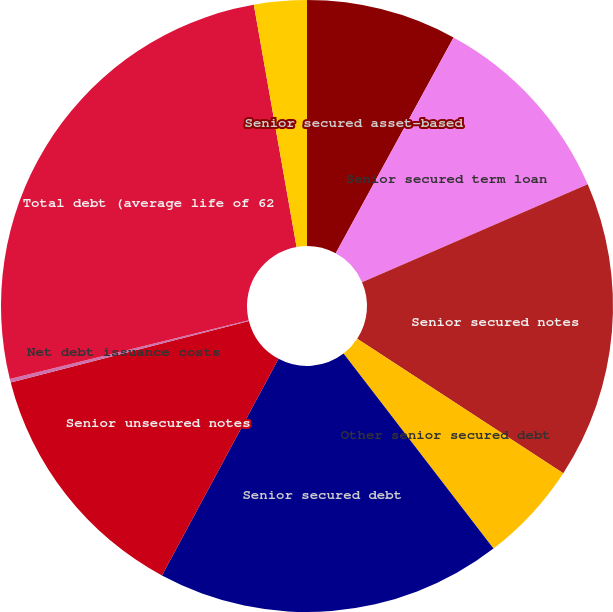Convert chart to OTSL. <chart><loc_0><loc_0><loc_500><loc_500><pie_chart><fcel>Senior secured asset-based<fcel>Senior secured term loan<fcel>Senior secured notes<fcel>Other senior secured debt<fcel>Senior secured debt<fcel>Senior unsecured notes<fcel>Net debt issuance costs<fcel>Total debt (average life of 62<fcel>Less amounts due within one<nl><fcel>7.95%<fcel>10.54%<fcel>15.71%<fcel>5.37%<fcel>18.29%<fcel>13.12%<fcel>0.19%<fcel>26.05%<fcel>2.78%<nl></chart> 